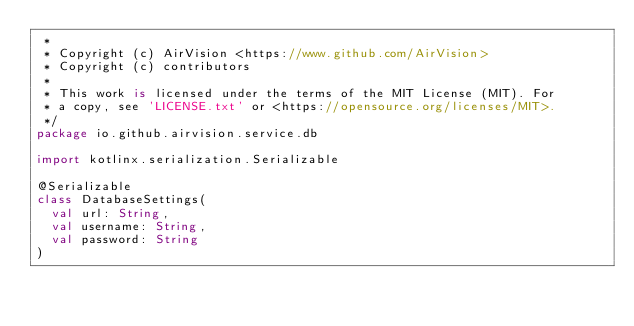<code> <loc_0><loc_0><loc_500><loc_500><_Kotlin_> *
 * Copyright (c) AirVision <https://www.github.com/AirVision>
 * Copyright (c) contributors
 *
 * This work is licensed under the terms of the MIT License (MIT). For
 * a copy, see 'LICENSE.txt' or <https://opensource.org/licenses/MIT>.
 */
package io.github.airvision.service.db

import kotlinx.serialization.Serializable

@Serializable
class DatabaseSettings(
  val url: String,
  val username: String,
  val password: String
)
</code> 